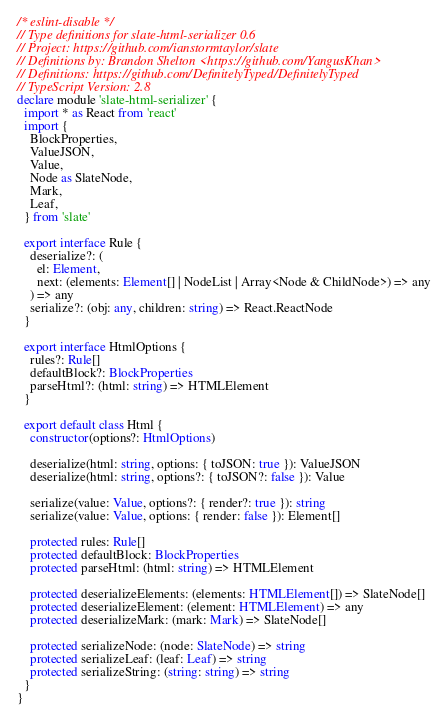Convert code to text. <code><loc_0><loc_0><loc_500><loc_500><_TypeScript_>/* eslint-disable */
// Type definitions for slate-html-serializer 0.6
// Project: https://github.com/ianstormtaylor/slate
// Definitions by: Brandon Shelton <https://github.com/YangusKhan>
// Definitions: https://github.com/DefinitelyTyped/DefinitelyTyped
// TypeScript Version: 2.8
declare module 'slate-html-serializer' {
  import * as React from 'react'
  import {
    BlockProperties,
    ValueJSON,
    Value,
    Node as SlateNode,
    Mark,
    Leaf,
  } from 'slate'

  export interface Rule {
    deserialize?: (
      el: Element,
      next: (elements: Element[] | NodeList | Array<Node & ChildNode>) => any
    ) => any
    serialize?: (obj: any, children: string) => React.ReactNode
  }

  export interface HtmlOptions {
    rules?: Rule[]
    defaultBlock?: BlockProperties
    parseHtml?: (html: string) => HTMLElement
  }

  export default class Html {
    constructor(options?: HtmlOptions)

    deserialize(html: string, options: { toJSON: true }): ValueJSON
    deserialize(html: string, options?: { toJSON?: false }): Value

    serialize(value: Value, options?: { render?: true }): string
    serialize(value: Value, options: { render: false }): Element[]

    protected rules: Rule[]
    protected defaultBlock: BlockProperties
    protected parseHtml: (html: string) => HTMLElement

    protected deserializeElements: (elements: HTMLElement[]) => SlateNode[]
    protected deserializeElement: (element: HTMLElement) => any
    protected deserializeMark: (mark: Mark) => SlateNode[]

    protected serializeNode: (node: SlateNode) => string
    protected serializeLeaf: (leaf: Leaf) => string
    protected serializeString: (string: string) => string
  }
}
</code> 